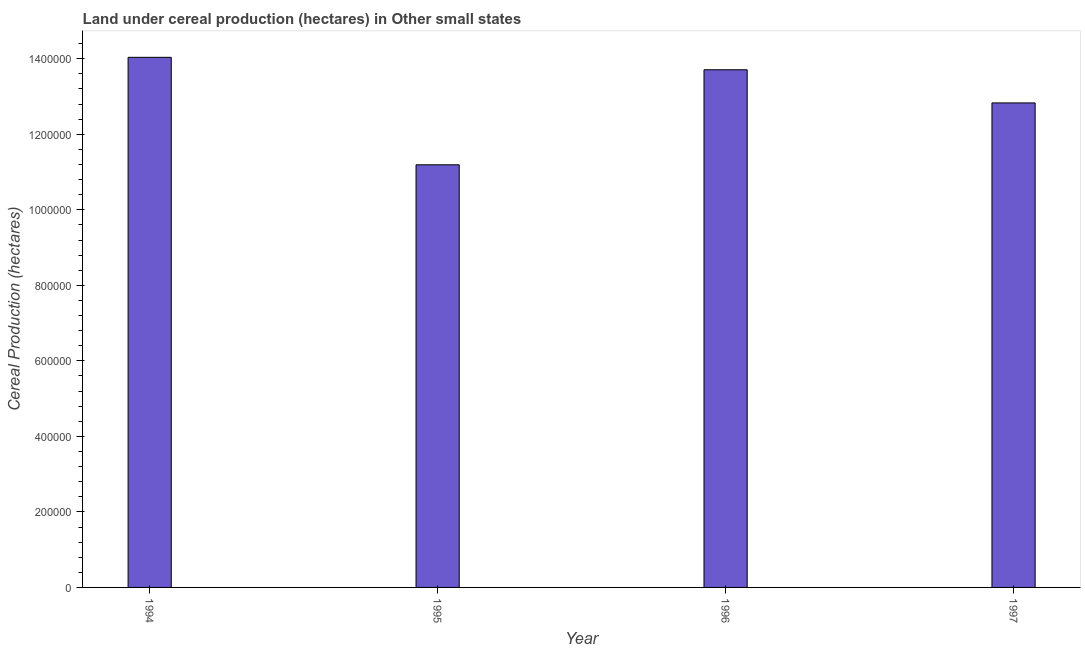Does the graph contain any zero values?
Your answer should be compact. No. Does the graph contain grids?
Make the answer very short. No. What is the title of the graph?
Make the answer very short. Land under cereal production (hectares) in Other small states. What is the label or title of the X-axis?
Provide a succinct answer. Year. What is the label or title of the Y-axis?
Give a very brief answer. Cereal Production (hectares). What is the land under cereal production in 1996?
Offer a very short reply. 1.37e+06. Across all years, what is the maximum land under cereal production?
Your response must be concise. 1.40e+06. Across all years, what is the minimum land under cereal production?
Provide a succinct answer. 1.12e+06. What is the sum of the land under cereal production?
Offer a very short reply. 5.18e+06. What is the difference between the land under cereal production in 1995 and 1996?
Provide a succinct answer. -2.52e+05. What is the average land under cereal production per year?
Make the answer very short. 1.29e+06. What is the median land under cereal production?
Make the answer very short. 1.33e+06. In how many years, is the land under cereal production greater than 1040000 hectares?
Provide a short and direct response. 4. Do a majority of the years between 1997 and 1996 (inclusive) have land under cereal production greater than 280000 hectares?
Provide a succinct answer. No. What is the ratio of the land under cereal production in 1995 to that in 1996?
Make the answer very short. 0.82. Is the difference between the land under cereal production in 1995 and 1997 greater than the difference between any two years?
Give a very brief answer. No. What is the difference between the highest and the second highest land under cereal production?
Offer a terse response. 3.29e+04. Is the sum of the land under cereal production in 1995 and 1997 greater than the maximum land under cereal production across all years?
Provide a succinct answer. Yes. What is the difference between the highest and the lowest land under cereal production?
Provide a succinct answer. 2.85e+05. In how many years, is the land under cereal production greater than the average land under cereal production taken over all years?
Your answer should be compact. 2. Are all the bars in the graph horizontal?
Your answer should be compact. No. What is the difference between two consecutive major ticks on the Y-axis?
Your answer should be compact. 2.00e+05. Are the values on the major ticks of Y-axis written in scientific E-notation?
Your response must be concise. No. What is the Cereal Production (hectares) in 1994?
Keep it short and to the point. 1.40e+06. What is the Cereal Production (hectares) of 1995?
Provide a short and direct response. 1.12e+06. What is the Cereal Production (hectares) of 1996?
Provide a short and direct response. 1.37e+06. What is the Cereal Production (hectares) of 1997?
Your answer should be compact. 1.28e+06. What is the difference between the Cereal Production (hectares) in 1994 and 1995?
Offer a very short reply. 2.85e+05. What is the difference between the Cereal Production (hectares) in 1994 and 1996?
Keep it short and to the point. 3.29e+04. What is the difference between the Cereal Production (hectares) in 1994 and 1997?
Your answer should be very brief. 1.21e+05. What is the difference between the Cereal Production (hectares) in 1995 and 1996?
Offer a terse response. -2.52e+05. What is the difference between the Cereal Production (hectares) in 1995 and 1997?
Provide a succinct answer. -1.64e+05. What is the difference between the Cereal Production (hectares) in 1996 and 1997?
Ensure brevity in your answer.  8.78e+04. What is the ratio of the Cereal Production (hectares) in 1994 to that in 1995?
Give a very brief answer. 1.25. What is the ratio of the Cereal Production (hectares) in 1994 to that in 1996?
Keep it short and to the point. 1.02. What is the ratio of the Cereal Production (hectares) in 1994 to that in 1997?
Provide a short and direct response. 1.09. What is the ratio of the Cereal Production (hectares) in 1995 to that in 1996?
Your answer should be very brief. 0.82. What is the ratio of the Cereal Production (hectares) in 1995 to that in 1997?
Your answer should be very brief. 0.87. What is the ratio of the Cereal Production (hectares) in 1996 to that in 1997?
Keep it short and to the point. 1.07. 